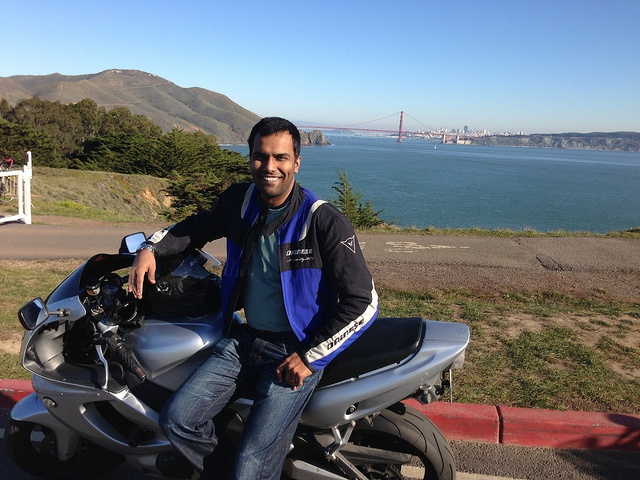Describe the objects in this image and their specific colors. I can see motorcycle in lightblue, black, gray, and darkgray tones and people in lightblue, black, gray, navy, and darkblue tones in this image. 